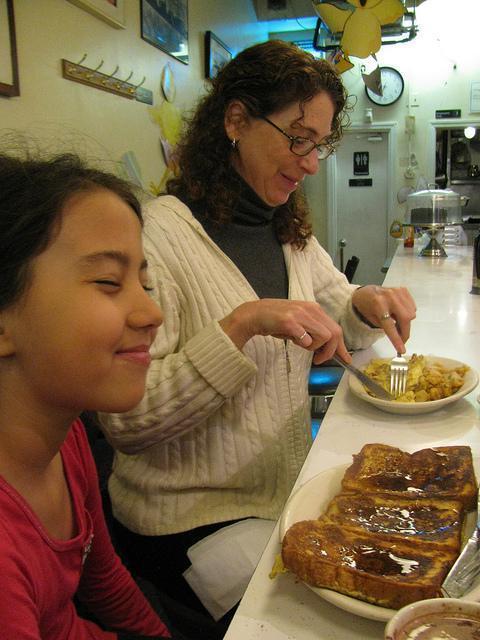Does the image validate the caption "The sandwich is at the edge of the dining table."?
Answer yes or no. Yes. 